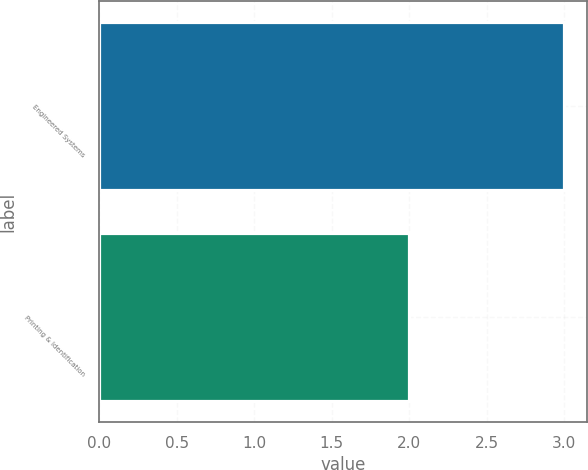Convert chart to OTSL. <chart><loc_0><loc_0><loc_500><loc_500><bar_chart><fcel>Engineered Systems<fcel>Printing & Identification<nl><fcel>3<fcel>2<nl></chart> 